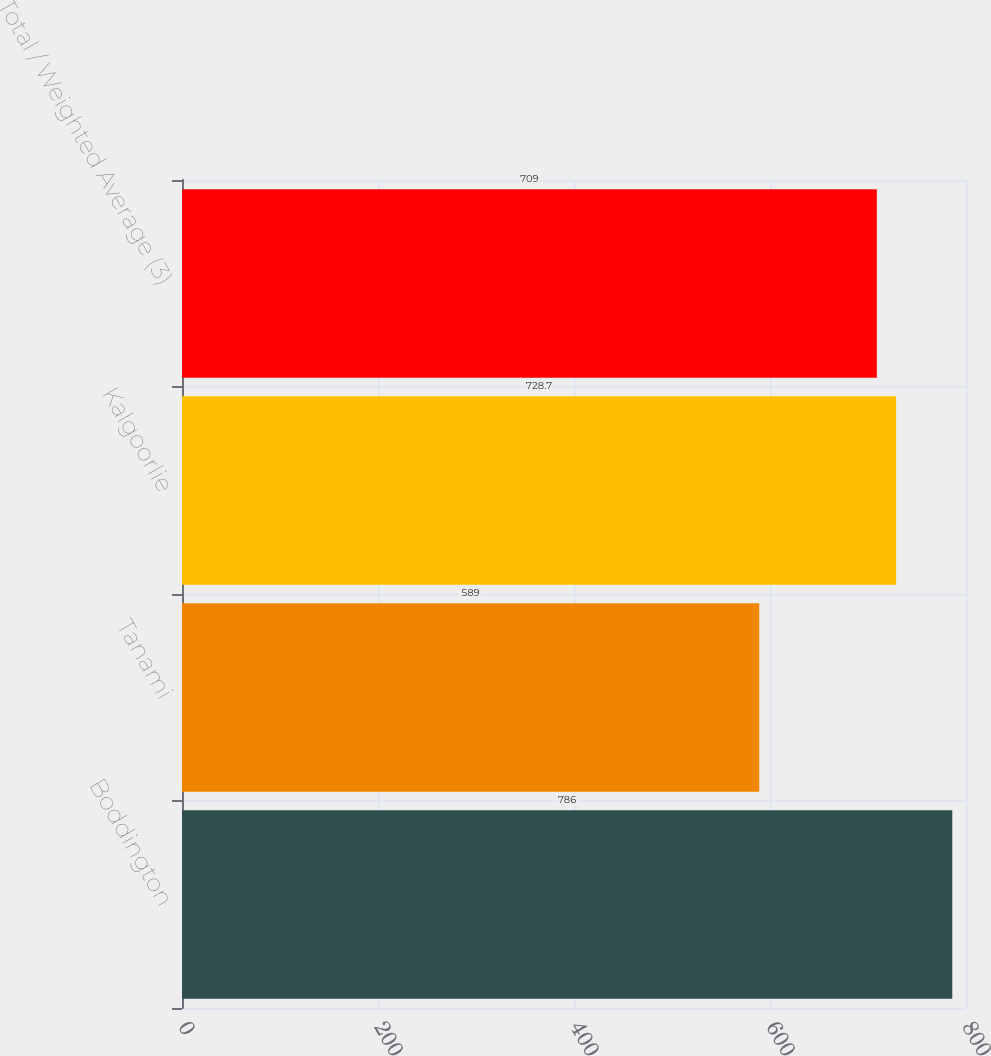Convert chart to OTSL. <chart><loc_0><loc_0><loc_500><loc_500><bar_chart><fcel>Boddington<fcel>Tanami<fcel>Kalgoorlie<fcel>Total / Weighted Average (3)<nl><fcel>786<fcel>589<fcel>728.7<fcel>709<nl></chart> 